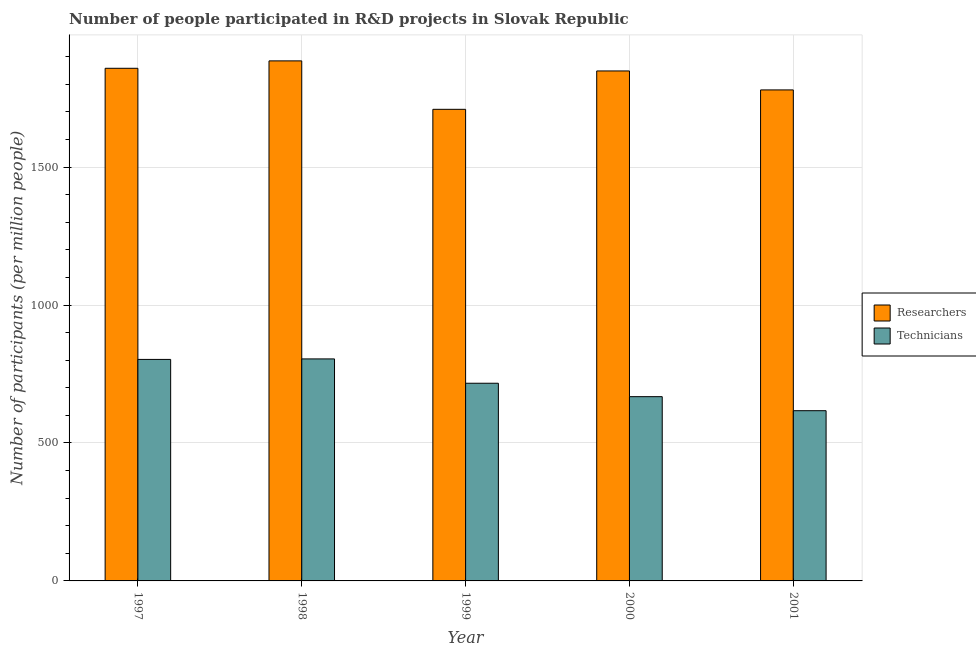How many different coloured bars are there?
Offer a terse response. 2. How many groups of bars are there?
Provide a short and direct response. 5. How many bars are there on the 1st tick from the right?
Offer a very short reply. 2. In how many cases, is the number of bars for a given year not equal to the number of legend labels?
Offer a terse response. 0. What is the number of researchers in 1997?
Ensure brevity in your answer.  1857.96. Across all years, what is the maximum number of researchers?
Your response must be concise. 1884.8. Across all years, what is the minimum number of researchers?
Make the answer very short. 1709.24. What is the total number of researchers in the graph?
Your response must be concise. 9079.83. What is the difference between the number of researchers in 1997 and that in 1999?
Keep it short and to the point. 148.72. What is the difference between the number of researchers in 2000 and the number of technicians in 2001?
Your answer should be compact. 68.75. What is the average number of technicians per year?
Offer a terse response. 721.74. In the year 1998, what is the difference between the number of researchers and number of technicians?
Provide a short and direct response. 0. What is the ratio of the number of researchers in 1997 to that in 2001?
Provide a succinct answer. 1.04. Is the number of technicians in 1998 less than that in 2001?
Your answer should be very brief. No. What is the difference between the highest and the second highest number of technicians?
Provide a short and direct response. 1.81. What is the difference between the highest and the lowest number of researchers?
Provide a succinct answer. 175.57. In how many years, is the number of researchers greater than the average number of researchers taken over all years?
Keep it short and to the point. 3. Is the sum of the number of technicians in 1998 and 1999 greater than the maximum number of researchers across all years?
Give a very brief answer. Yes. What does the 2nd bar from the left in 2000 represents?
Provide a succinct answer. Technicians. What does the 1st bar from the right in 1997 represents?
Keep it short and to the point. Technicians. How many bars are there?
Your answer should be compact. 10. Does the graph contain grids?
Give a very brief answer. Yes. How are the legend labels stacked?
Offer a very short reply. Vertical. What is the title of the graph?
Give a very brief answer. Number of people participated in R&D projects in Slovak Republic. Does "Personal remittances" appear as one of the legend labels in the graph?
Give a very brief answer. No. What is the label or title of the X-axis?
Ensure brevity in your answer.  Year. What is the label or title of the Y-axis?
Ensure brevity in your answer.  Number of participants (per million people). What is the Number of participants (per million people) of Researchers in 1997?
Give a very brief answer. 1857.96. What is the Number of participants (per million people) in Technicians in 1997?
Keep it short and to the point. 802.83. What is the Number of participants (per million people) of Researchers in 1998?
Offer a very short reply. 1884.8. What is the Number of participants (per million people) in Technicians in 1998?
Offer a terse response. 804.64. What is the Number of participants (per million people) in Researchers in 1999?
Provide a succinct answer. 1709.24. What is the Number of participants (per million people) in Technicians in 1999?
Provide a short and direct response. 716.45. What is the Number of participants (per million people) of Researchers in 2000?
Keep it short and to the point. 1848.29. What is the Number of participants (per million people) of Technicians in 2000?
Provide a short and direct response. 667.83. What is the Number of participants (per million people) of Researchers in 2001?
Ensure brevity in your answer.  1779.54. What is the Number of participants (per million people) of Technicians in 2001?
Your answer should be very brief. 616.94. Across all years, what is the maximum Number of participants (per million people) in Researchers?
Your answer should be very brief. 1884.8. Across all years, what is the maximum Number of participants (per million people) in Technicians?
Your answer should be very brief. 804.64. Across all years, what is the minimum Number of participants (per million people) in Researchers?
Ensure brevity in your answer.  1709.24. Across all years, what is the minimum Number of participants (per million people) in Technicians?
Make the answer very short. 616.94. What is the total Number of participants (per million people) in Researchers in the graph?
Your response must be concise. 9079.83. What is the total Number of participants (per million people) of Technicians in the graph?
Your answer should be compact. 3608.7. What is the difference between the Number of participants (per million people) of Researchers in 1997 and that in 1998?
Give a very brief answer. -26.85. What is the difference between the Number of participants (per million people) in Technicians in 1997 and that in 1998?
Make the answer very short. -1.81. What is the difference between the Number of participants (per million people) of Researchers in 1997 and that in 1999?
Keep it short and to the point. 148.72. What is the difference between the Number of participants (per million people) of Technicians in 1997 and that in 1999?
Ensure brevity in your answer.  86.37. What is the difference between the Number of participants (per million people) of Researchers in 1997 and that in 2000?
Your answer should be compact. 9.67. What is the difference between the Number of participants (per million people) in Technicians in 1997 and that in 2000?
Make the answer very short. 134.99. What is the difference between the Number of participants (per million people) in Researchers in 1997 and that in 2001?
Offer a terse response. 78.42. What is the difference between the Number of participants (per million people) of Technicians in 1997 and that in 2001?
Ensure brevity in your answer.  185.88. What is the difference between the Number of participants (per million people) in Researchers in 1998 and that in 1999?
Your response must be concise. 175.57. What is the difference between the Number of participants (per million people) of Technicians in 1998 and that in 1999?
Your answer should be compact. 88.19. What is the difference between the Number of participants (per million people) in Researchers in 1998 and that in 2000?
Offer a terse response. 36.52. What is the difference between the Number of participants (per million people) in Technicians in 1998 and that in 2000?
Keep it short and to the point. 136.81. What is the difference between the Number of participants (per million people) of Researchers in 1998 and that in 2001?
Your answer should be very brief. 105.26. What is the difference between the Number of participants (per million people) of Technicians in 1998 and that in 2001?
Offer a terse response. 187.7. What is the difference between the Number of participants (per million people) in Researchers in 1999 and that in 2000?
Give a very brief answer. -139.05. What is the difference between the Number of participants (per million people) in Technicians in 1999 and that in 2000?
Provide a succinct answer. 48.62. What is the difference between the Number of participants (per million people) of Researchers in 1999 and that in 2001?
Offer a very short reply. -70.3. What is the difference between the Number of participants (per million people) of Technicians in 1999 and that in 2001?
Provide a short and direct response. 99.51. What is the difference between the Number of participants (per million people) of Researchers in 2000 and that in 2001?
Your answer should be very brief. 68.75. What is the difference between the Number of participants (per million people) of Technicians in 2000 and that in 2001?
Your answer should be compact. 50.89. What is the difference between the Number of participants (per million people) of Researchers in 1997 and the Number of participants (per million people) of Technicians in 1998?
Your response must be concise. 1053.31. What is the difference between the Number of participants (per million people) of Researchers in 1997 and the Number of participants (per million people) of Technicians in 1999?
Offer a terse response. 1141.5. What is the difference between the Number of participants (per million people) of Researchers in 1997 and the Number of participants (per million people) of Technicians in 2000?
Your answer should be very brief. 1190.12. What is the difference between the Number of participants (per million people) of Researchers in 1997 and the Number of participants (per million people) of Technicians in 2001?
Give a very brief answer. 1241.01. What is the difference between the Number of participants (per million people) of Researchers in 1998 and the Number of participants (per million people) of Technicians in 1999?
Offer a very short reply. 1168.35. What is the difference between the Number of participants (per million people) in Researchers in 1998 and the Number of participants (per million people) in Technicians in 2000?
Give a very brief answer. 1216.97. What is the difference between the Number of participants (per million people) in Researchers in 1998 and the Number of participants (per million people) in Technicians in 2001?
Your answer should be compact. 1267.86. What is the difference between the Number of participants (per million people) of Researchers in 1999 and the Number of participants (per million people) of Technicians in 2000?
Your answer should be very brief. 1041.4. What is the difference between the Number of participants (per million people) in Researchers in 1999 and the Number of participants (per million people) in Technicians in 2001?
Provide a succinct answer. 1092.29. What is the difference between the Number of participants (per million people) of Researchers in 2000 and the Number of participants (per million people) of Technicians in 2001?
Your answer should be very brief. 1231.34. What is the average Number of participants (per million people) of Researchers per year?
Give a very brief answer. 1815.97. What is the average Number of participants (per million people) of Technicians per year?
Ensure brevity in your answer.  721.74. In the year 1997, what is the difference between the Number of participants (per million people) in Researchers and Number of participants (per million people) in Technicians?
Provide a short and direct response. 1055.13. In the year 1998, what is the difference between the Number of participants (per million people) in Researchers and Number of participants (per million people) in Technicians?
Your answer should be very brief. 1080.16. In the year 1999, what is the difference between the Number of participants (per million people) in Researchers and Number of participants (per million people) in Technicians?
Offer a terse response. 992.78. In the year 2000, what is the difference between the Number of participants (per million people) of Researchers and Number of participants (per million people) of Technicians?
Your response must be concise. 1180.45. In the year 2001, what is the difference between the Number of participants (per million people) of Researchers and Number of participants (per million people) of Technicians?
Give a very brief answer. 1162.6. What is the ratio of the Number of participants (per million people) in Researchers in 1997 to that in 1998?
Offer a terse response. 0.99. What is the ratio of the Number of participants (per million people) in Technicians in 1997 to that in 1998?
Ensure brevity in your answer.  1. What is the ratio of the Number of participants (per million people) in Researchers in 1997 to that in 1999?
Keep it short and to the point. 1.09. What is the ratio of the Number of participants (per million people) of Technicians in 1997 to that in 1999?
Keep it short and to the point. 1.12. What is the ratio of the Number of participants (per million people) of Researchers in 1997 to that in 2000?
Your response must be concise. 1.01. What is the ratio of the Number of participants (per million people) of Technicians in 1997 to that in 2000?
Offer a terse response. 1.2. What is the ratio of the Number of participants (per million people) of Researchers in 1997 to that in 2001?
Keep it short and to the point. 1.04. What is the ratio of the Number of participants (per million people) in Technicians in 1997 to that in 2001?
Your answer should be very brief. 1.3. What is the ratio of the Number of participants (per million people) of Researchers in 1998 to that in 1999?
Offer a terse response. 1.1. What is the ratio of the Number of participants (per million people) of Technicians in 1998 to that in 1999?
Give a very brief answer. 1.12. What is the ratio of the Number of participants (per million people) in Researchers in 1998 to that in 2000?
Offer a very short reply. 1.02. What is the ratio of the Number of participants (per million people) in Technicians in 1998 to that in 2000?
Keep it short and to the point. 1.2. What is the ratio of the Number of participants (per million people) in Researchers in 1998 to that in 2001?
Your answer should be very brief. 1.06. What is the ratio of the Number of participants (per million people) in Technicians in 1998 to that in 2001?
Offer a very short reply. 1.3. What is the ratio of the Number of participants (per million people) in Researchers in 1999 to that in 2000?
Ensure brevity in your answer.  0.92. What is the ratio of the Number of participants (per million people) in Technicians in 1999 to that in 2000?
Make the answer very short. 1.07. What is the ratio of the Number of participants (per million people) in Researchers in 1999 to that in 2001?
Your response must be concise. 0.96. What is the ratio of the Number of participants (per million people) in Technicians in 1999 to that in 2001?
Provide a succinct answer. 1.16. What is the ratio of the Number of participants (per million people) in Researchers in 2000 to that in 2001?
Provide a short and direct response. 1.04. What is the ratio of the Number of participants (per million people) in Technicians in 2000 to that in 2001?
Make the answer very short. 1.08. What is the difference between the highest and the second highest Number of participants (per million people) in Researchers?
Your answer should be compact. 26.85. What is the difference between the highest and the second highest Number of participants (per million people) of Technicians?
Your response must be concise. 1.81. What is the difference between the highest and the lowest Number of participants (per million people) in Researchers?
Your answer should be very brief. 175.57. What is the difference between the highest and the lowest Number of participants (per million people) of Technicians?
Your answer should be very brief. 187.7. 